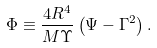Convert formula to latex. <formula><loc_0><loc_0><loc_500><loc_500>\Phi \equiv \frac { 4 R ^ { 4 } } { M \Upsilon } \left ( \Psi - \Gamma ^ { 2 } \right ) .</formula> 